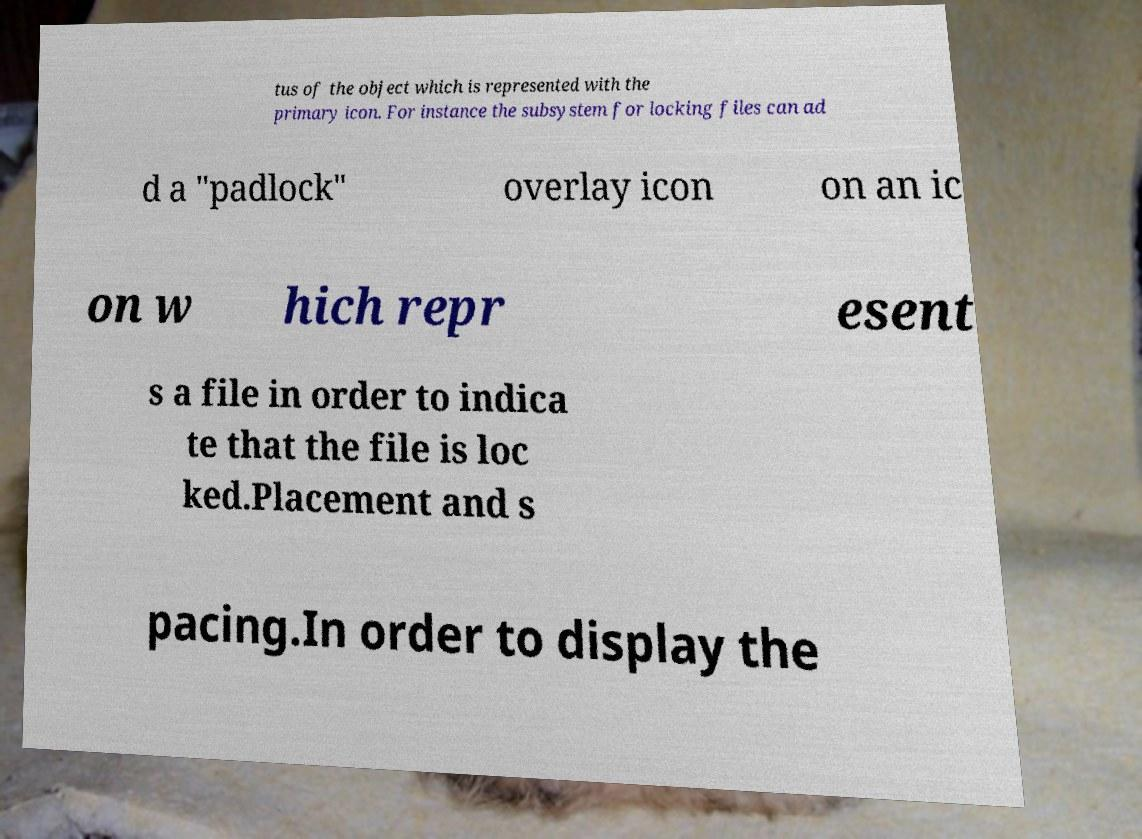Could you extract and type out the text from this image? tus of the object which is represented with the primary icon. For instance the subsystem for locking files can ad d a "padlock" overlay icon on an ic on w hich repr esent s a file in order to indica te that the file is loc ked.Placement and s pacing.In order to display the 